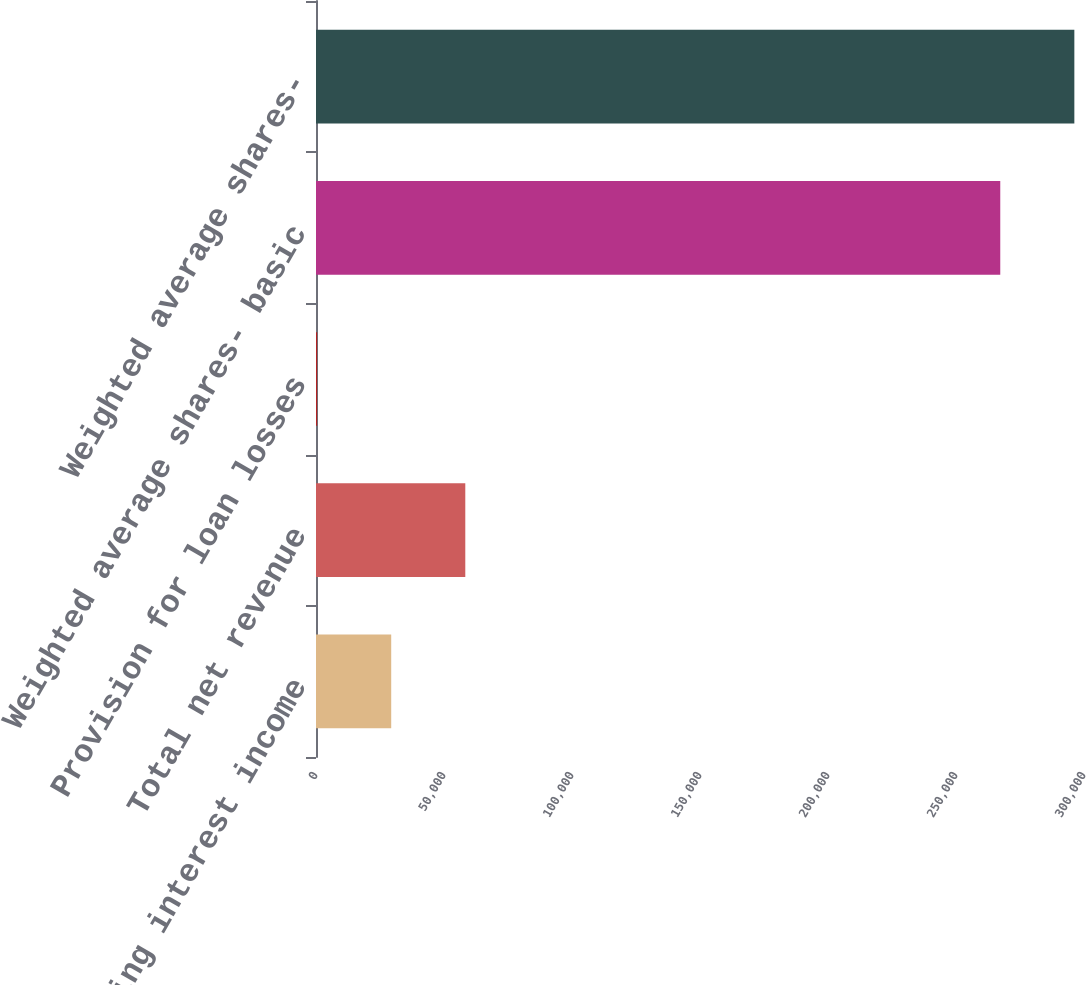Convert chart to OTSL. <chart><loc_0><loc_0><loc_500><loc_500><bar_chart><fcel>Net operating interest income<fcel>Total net revenue<fcel>Provision for loan losses<fcel>Weighted average shares- basic<fcel>Weighted average shares-<nl><fcel>29378.7<fcel>58316.9<fcel>440.6<fcel>267291<fcel>296229<nl></chart> 